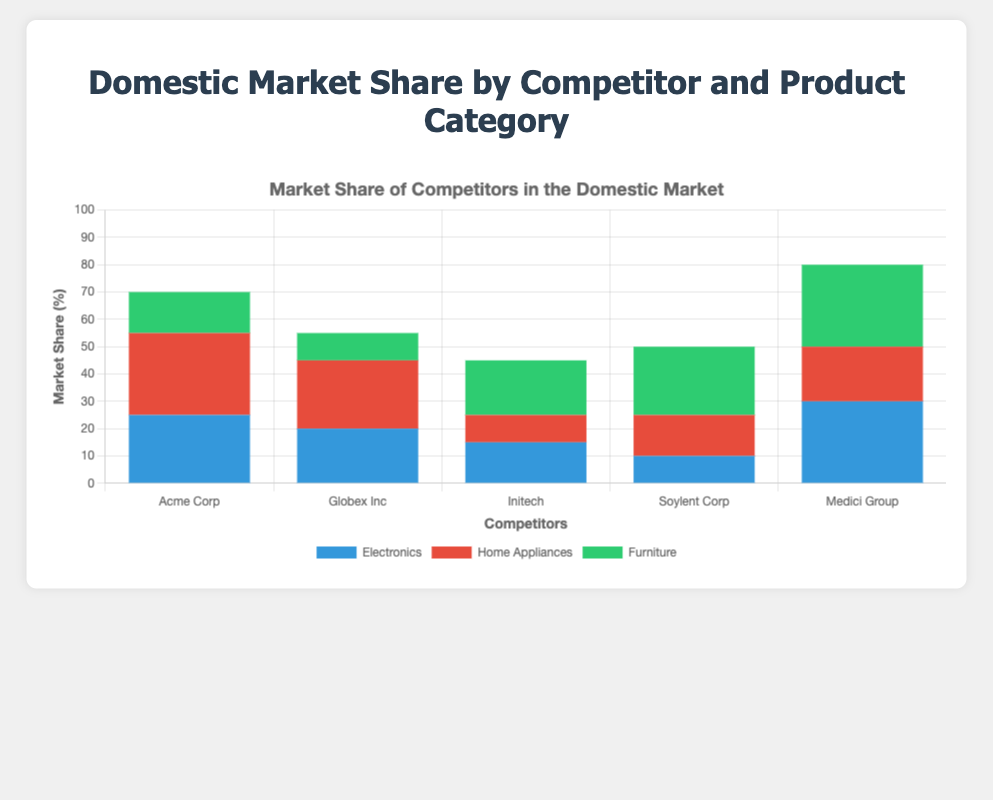What is the total market share percentage of Acme Corp across all product categories? To find the total market share percentage, add Acme Corp's market share in Electronics (25%), Home Appliances (30%), and Furniture (15%). So, 25 + 30 + 15 = 70.
Answer: 70% Which competitor has the highest market share in the Furniture category? For Furniture, the market share percentages are: Acme Corp (15%), Globex Inc (10%), Initech (20%), Soylent Corp (25%), and Medici Group (30%). Among these, Medici Group has the highest market share.
Answer: Medici Group How do the market share percentages of Medici Group's Electronics and Home Appliances categories compare? Medici Group has a 30% market share in Electronics and 20% in Home Appliances. Therefore, Medici Group's market share in Electronics is 10% higher than in Home Appliances.
Answer: 10% higher What is the combined market share for Furniture products between Initech and Soylent Corp? Initech's market share for Furniture is 20% and Soylent Corp's market share is 25%. Therefore, the combined market share is 20 + 25 = 45.
Answer: 45% Compare the total market share percentages of Home Appliances for Acme Corp and Globex Inc. Acme Corp has a 30% market share in Home Appliances, and Globex Inc has a 25% market share. Therefore, Acme Corp has a 5% higher market share in Home Appliances than Globex Inc.
Answer: 5% higher Which product category has the least total market share across all competitors? Summing up the market shares across all competitors for each category: Electronics (25+20+15+10+30=100), Home Appliances (30+25+10+15+20=100), Furniture (15+10+20+25+30=100). All categories have the same total market share of 100%.
Answer: All categories are equal What is Globex Inc's average market share percentage across all product categories? Adding up Globex Inc's market share: Electronics (20%), Home Appliances (25%), and Furniture (10%), and then dividing by 3. The average is (20 + 25 + 10) / 3 = 18.33.
Answer: 18.33% What visual feature indicates the relative market share distribution among competitors for each product category? The height of the stacked bar sections represents the market share percentage. Taller sections indicate a higher market share.
Answer: Height of the stacked bar sections Which competitor has the most balanced distribution of market share percentage across all product categories? By checking each competitor: Acme Corp (25%, 30%, 15%), Globex Inc (20%, 25%, 10%), Initech (15%, 10%, 20%), Soylent Corp (10%, 15%, 25%), Medici Group (30%, 20%, 30%). Initech has the closest distribution with values 15%, 10%, and 20%.
Answer: Initech 